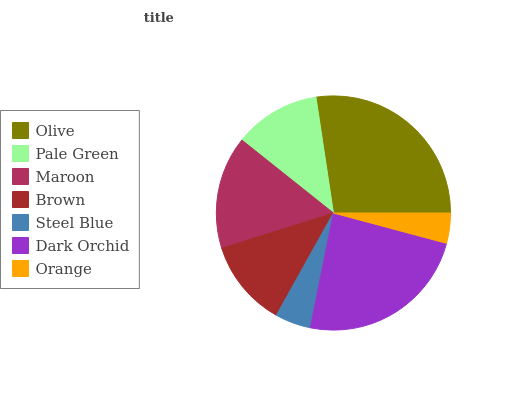Is Orange the minimum?
Answer yes or no. Yes. Is Olive the maximum?
Answer yes or no. Yes. Is Pale Green the minimum?
Answer yes or no. No. Is Pale Green the maximum?
Answer yes or no. No. Is Olive greater than Pale Green?
Answer yes or no. Yes. Is Pale Green less than Olive?
Answer yes or no. Yes. Is Pale Green greater than Olive?
Answer yes or no. No. Is Olive less than Pale Green?
Answer yes or no. No. Is Brown the high median?
Answer yes or no. Yes. Is Brown the low median?
Answer yes or no. Yes. Is Dark Orchid the high median?
Answer yes or no. No. Is Olive the low median?
Answer yes or no. No. 